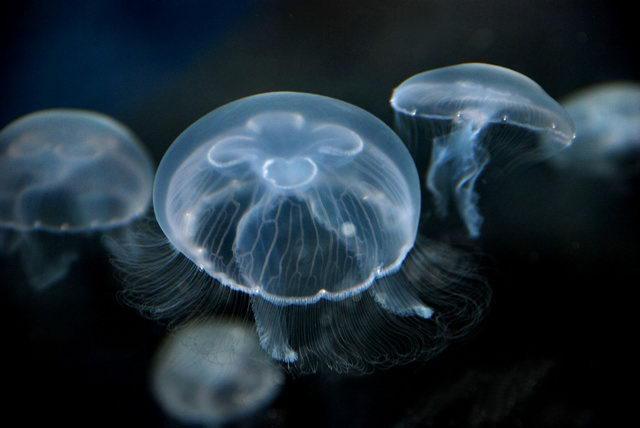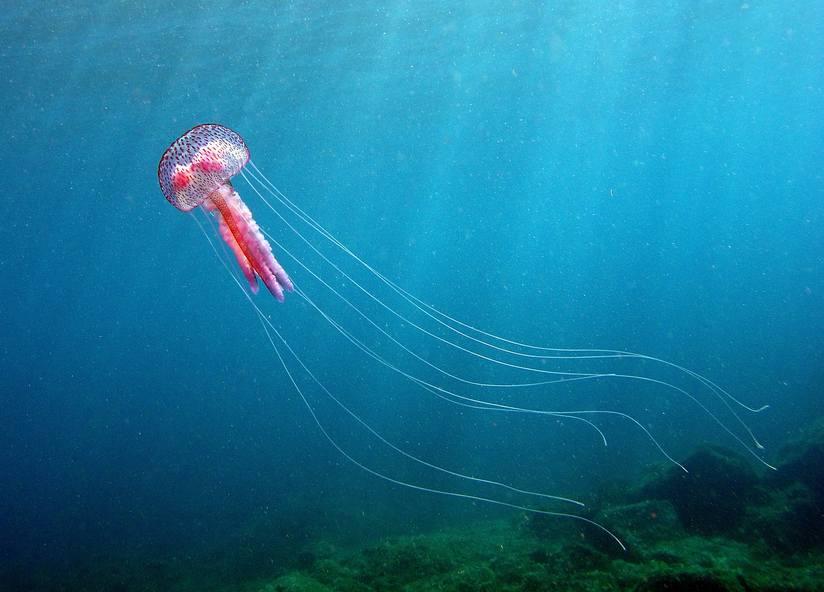The first image is the image on the left, the second image is the image on the right. Examine the images to the left and right. Is the description "An image shows a white jellyfish with its 'mushroom cap' heading rightward." accurate? Answer yes or no. No. The first image is the image on the left, the second image is the image on the right. For the images shown, is this caption "A single white jellyfish is traveling towards the right in one of the images." true? Answer yes or no. No. 